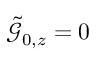<formula> <loc_0><loc_0><loc_500><loc_500>\tilde { \mathcal { G } } _ { 0 , z } = 0</formula> 